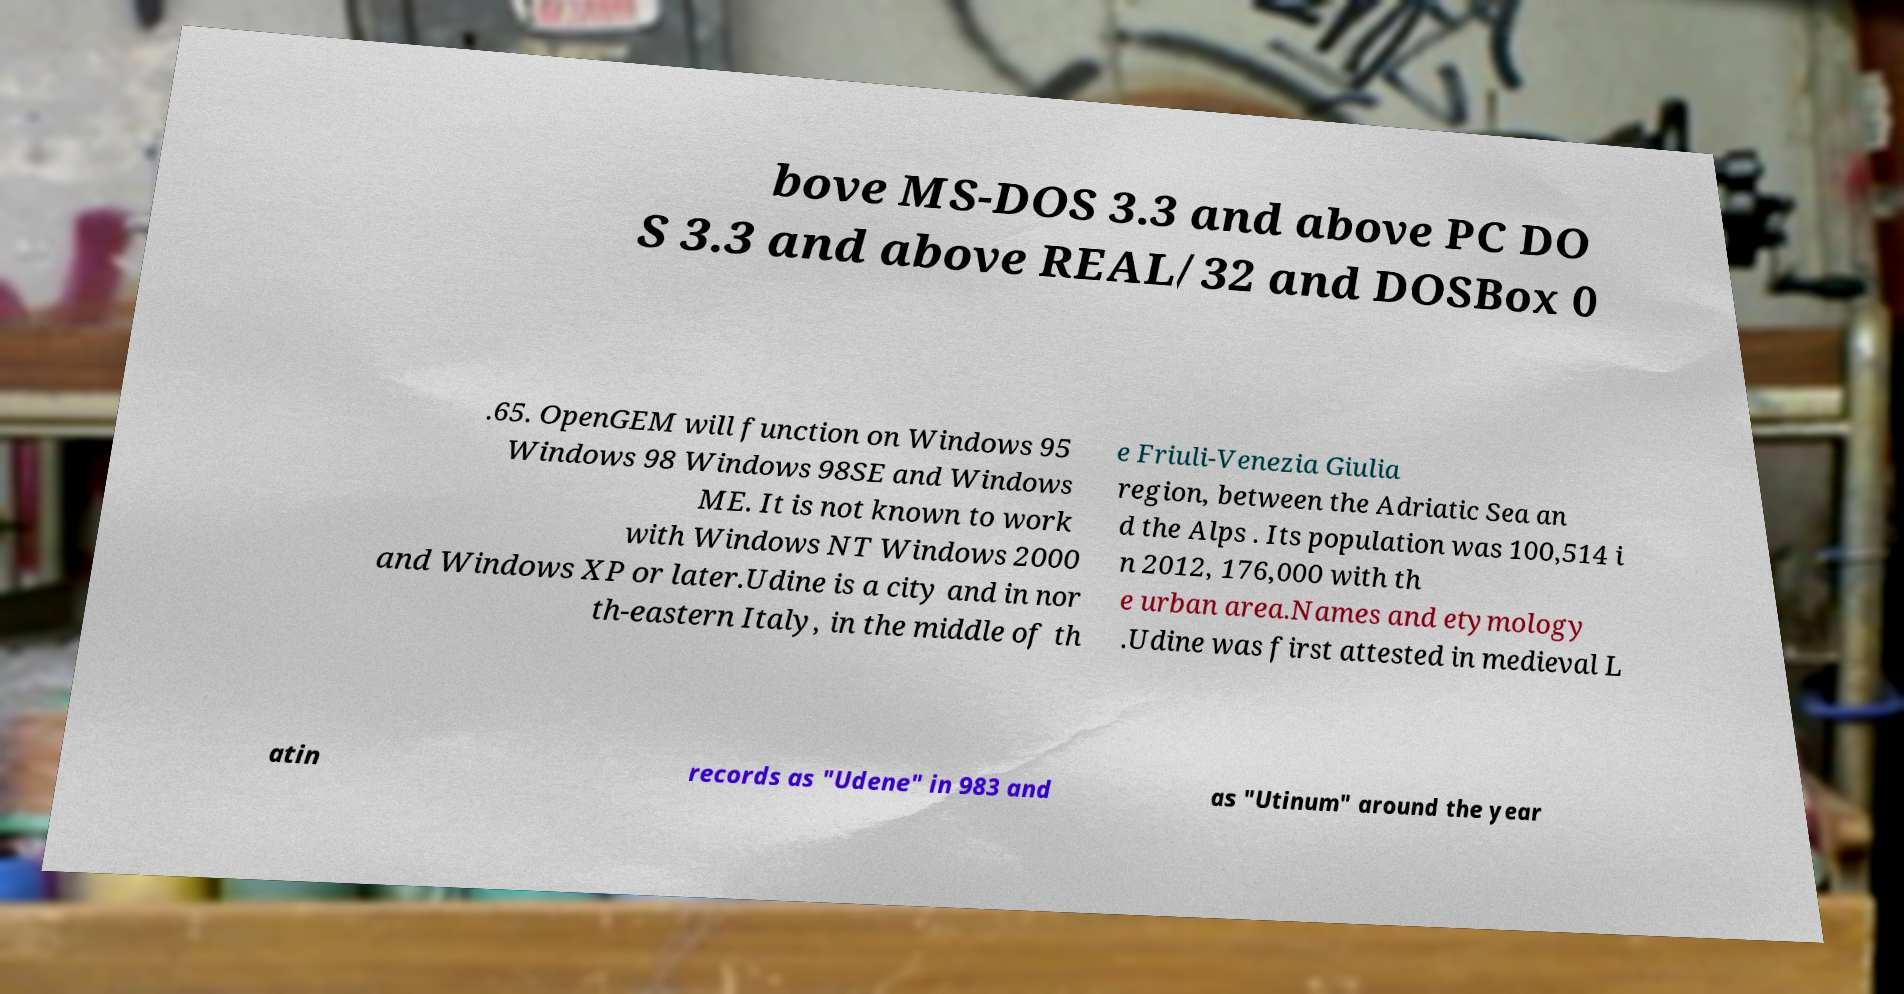Please read and relay the text visible in this image. What does it say? bove MS-DOS 3.3 and above PC DO S 3.3 and above REAL/32 and DOSBox 0 .65. OpenGEM will function on Windows 95 Windows 98 Windows 98SE and Windows ME. It is not known to work with Windows NT Windows 2000 and Windows XP or later.Udine is a city and in nor th-eastern Italy, in the middle of th e Friuli-Venezia Giulia region, between the Adriatic Sea an d the Alps . Its population was 100,514 i n 2012, 176,000 with th e urban area.Names and etymology .Udine was first attested in medieval L atin records as "Udene" in 983 and as "Utinum" around the year 